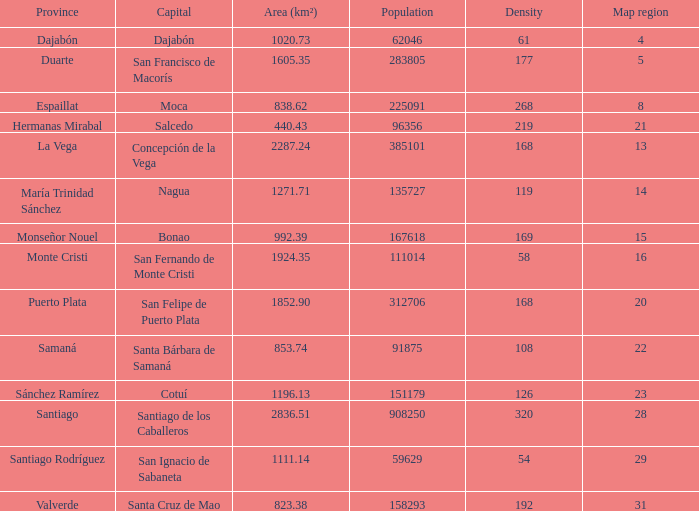When area (km²) is 1605.35, how many provinces are there? 1.0. 